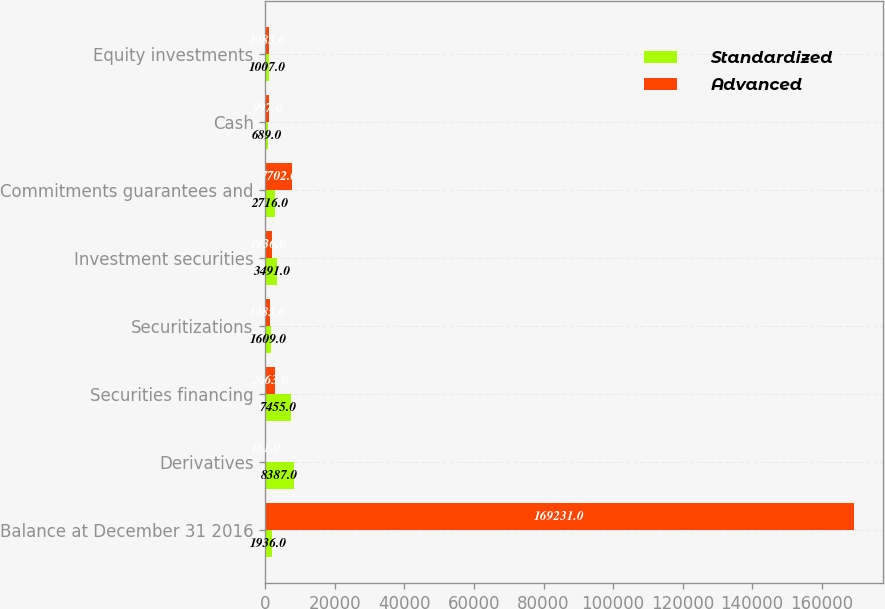Convert chart. <chart><loc_0><loc_0><loc_500><loc_500><stacked_bar_chart><ecel><fcel>Balance at December 31 2016<fcel>Derivatives<fcel>Securities financing<fcel>Securitizations<fcel>Investment securities<fcel>Commitments guarantees and<fcel>Cash<fcel>Equity investments<nl><fcel>Standardized<fcel>1936<fcel>8387<fcel>7455<fcel>1609<fcel>3491<fcel>2716<fcel>689<fcel>1007<nl><fcel>Advanced<fcel>169231<fcel>181<fcel>2663<fcel>1485<fcel>1936<fcel>7702<fcel>997<fcel>1085<nl></chart> 